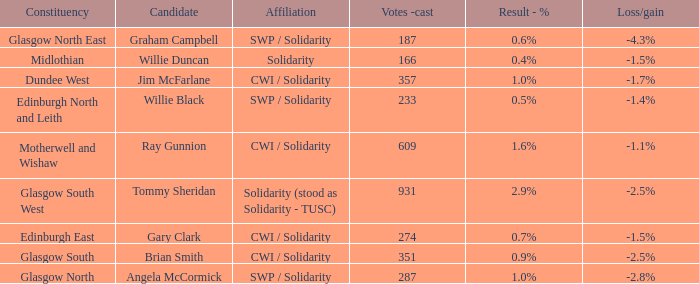What was the loss/gain when the affiliation was solidarity? -1.5%. 